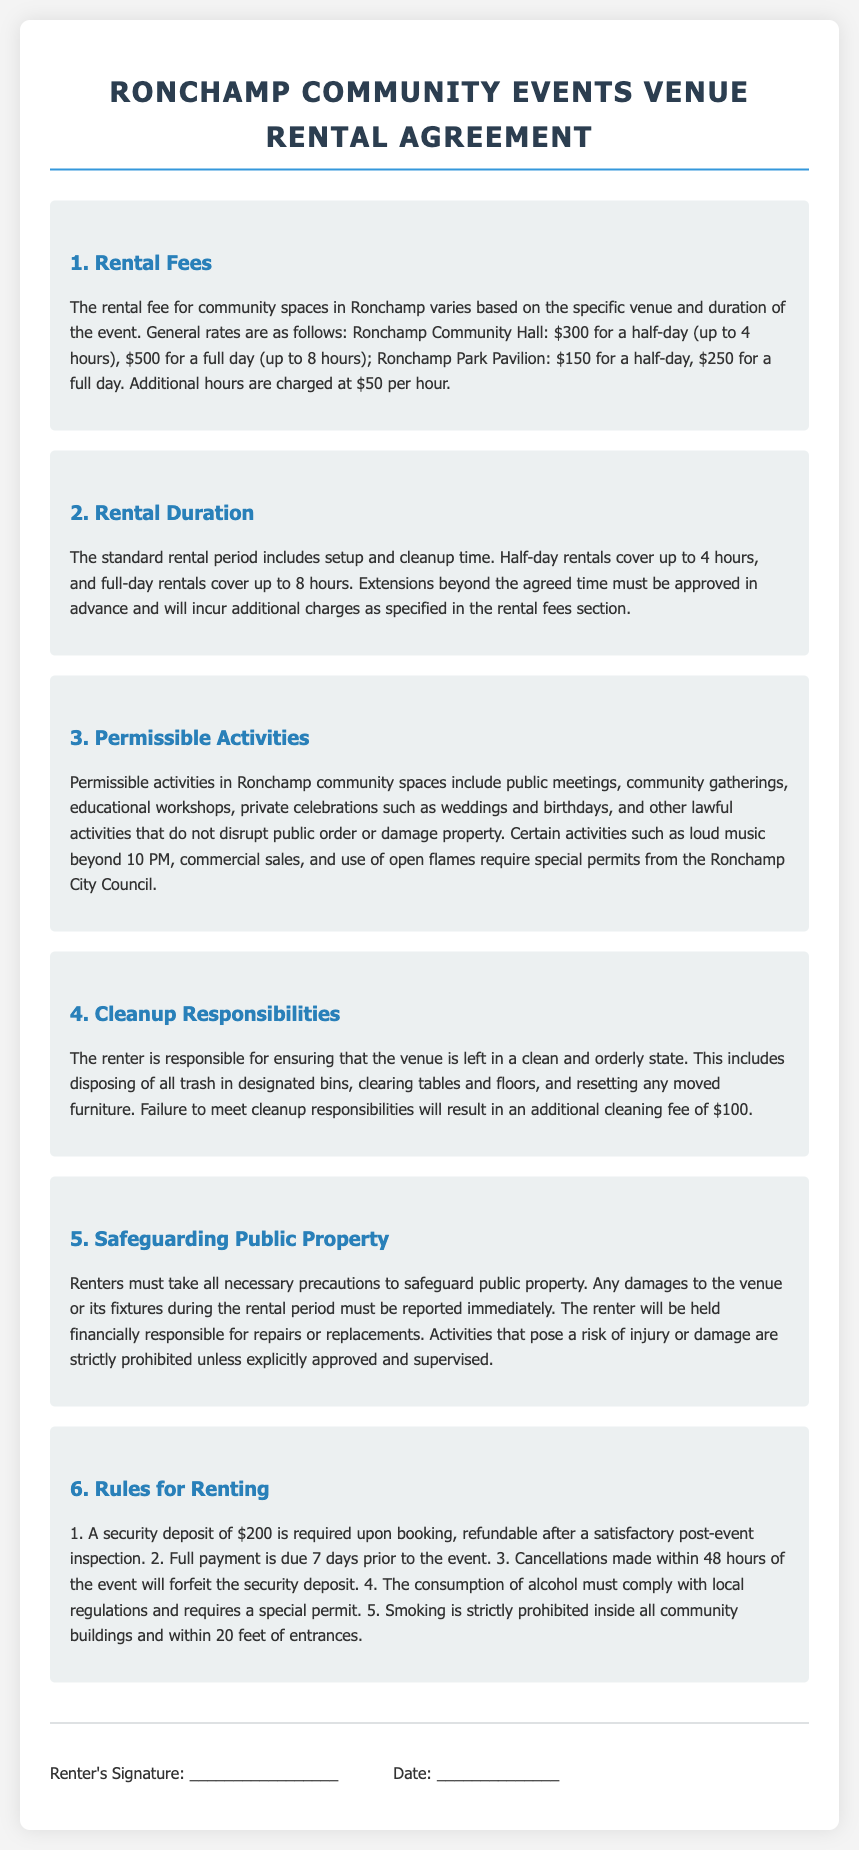What is the half-day rental fee for the Community Hall? The half-day rental fee for the Community Hall is specified in the rental fees section of the document.
Answer: $300 What is the maximum duration for a full-day rental? The full-day rental duration is outlined in the rental duration section, detailing the maximum hours allowed.
Answer: 8 hours What additional fee applies for extra hours beyond the rental agreement? The document indicates the charge for additional hours in the rental fees section.
Answer: $50 per hour Which activities require special permits from the Ronchamp City Council? The permissible activities section lists specific activities needing permits due to potential disruption or risk.
Answer: Loud music beyond 10 PM, commercial sales, and use of open flames What is the cleaning fee for not meeting cleanup responsibilities? The cleanup responsibilities section specifies the fee for failing to properly clean the venue after the event.
Answer: $100 What is the security deposit amount for booking a venue? The document's rules for renting section mentions the security deposit required upon booking.
Answer: $200 What happens if a cancellation is made within 48 hours of the event? The cancellation policy is described under the rules for renting, outlining the consequences of late cancellations.
Answer: Forfeit the security deposit What are renters required to do if damages occur during the rental period? The safeguarding public property section clarifies the renter's obligations regarding damages to the venue.
Answer: Report immediately Is smoking allowed inside community buildings? The rules for renting section states the policy on smoking within venues.
Answer: No 